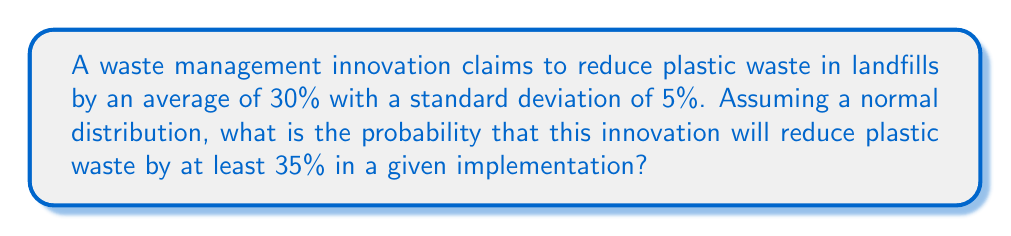Provide a solution to this math problem. To solve this problem, we need to use the properties of the normal distribution and calculate the z-score for the given value. Then, we'll use a standard normal distribution table or calculator to find the probability.

Step 1: Identify the given information
- Mean (μ) = 30%
- Standard deviation (σ) = 5%
- We want to find P(X ≥ 35%), where X is the percentage of plastic waste reduction

Step 2: Calculate the z-score
The z-score formula is: $z = \frac{x - μ}{σ}$

Where:
x = the value we're interested in (35%)
μ = mean (30%)
σ = standard deviation (5%)

Plugging in the values:

$z = \frac{35 - 30}{5} = \frac{5}{5} = 1$

Step 3: Find the probability using the standard normal distribution
We need to find P(Z ≥ 1), where Z is the standard normal random variable.

Using a standard normal distribution table or calculator, we can find that:
P(Z ≥ 1) = 1 - P(Z < 1) = 1 - 0.8413 = 0.1587

Step 4: Convert to percentage
0.1587 * 100 = 15.87%

Therefore, the probability that this innovation will reduce plastic waste by at least 35% in a given implementation is approximately 15.87%.
Answer: 15.87% 